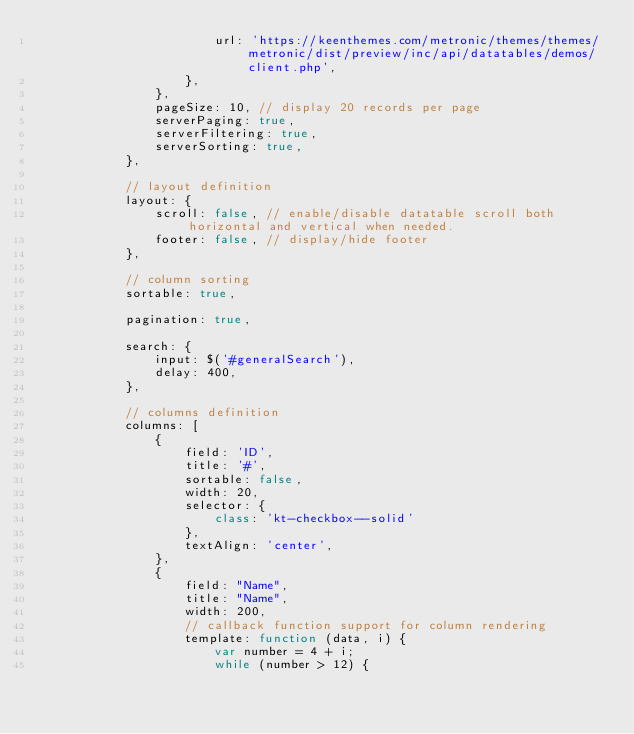Convert code to text. <code><loc_0><loc_0><loc_500><loc_500><_JavaScript_>                        url: 'https://keenthemes.com/metronic/themes/themes/metronic/dist/preview/inc/api/datatables/demos/client.php',
                    },
                },
                pageSize: 10, // display 20 records per page
                serverPaging: true,
                serverFiltering: true,
                serverSorting: true,
            },

            // layout definition
            layout: {
                scroll: false, // enable/disable datatable scroll both horizontal and vertical when needed.
                footer: false, // display/hide footer
            },

            // column sorting
            sortable: true,

            pagination: true,

            search: {
                input: $('#generalSearch'),
                delay: 400,
            },

            // columns definition
            columns: [
                {
                    field: 'ID',
                    title: '#',
                    sortable: false,
                    width: 20,
                    selector: {
                        class: 'kt-checkbox--solid'
                    },
                    textAlign: 'center',
                },
                {
                    field: "Name",
                    title: "Name",
                    width: 200,
                    // callback function support for column rendering
                    template: function (data, i) {
                        var number = 4 + i;
                        while (number > 12) {</code> 